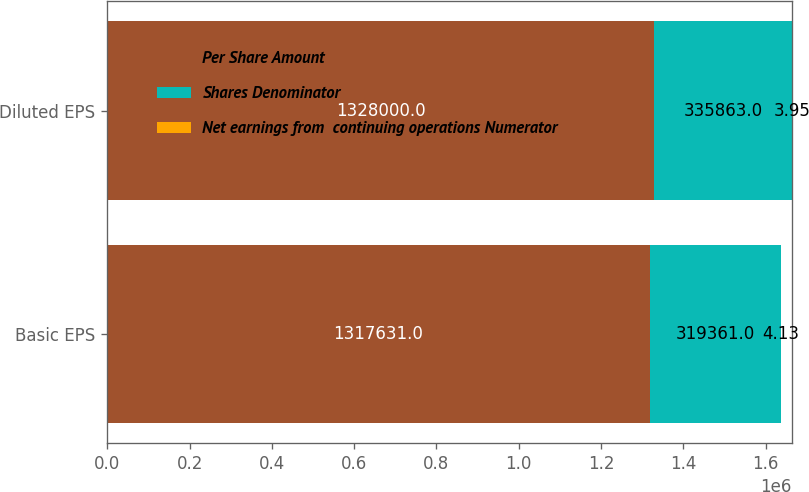Convert chart to OTSL. <chart><loc_0><loc_0><loc_500><loc_500><stacked_bar_chart><ecel><fcel>Basic EPS<fcel>Diluted EPS<nl><fcel>Per Share Amount<fcel>1.31763e+06<fcel>1.328e+06<nl><fcel>Shares Denominator<fcel>319361<fcel>335863<nl><fcel>Net earnings from  continuing operations Numerator<fcel>4.13<fcel>3.95<nl></chart> 